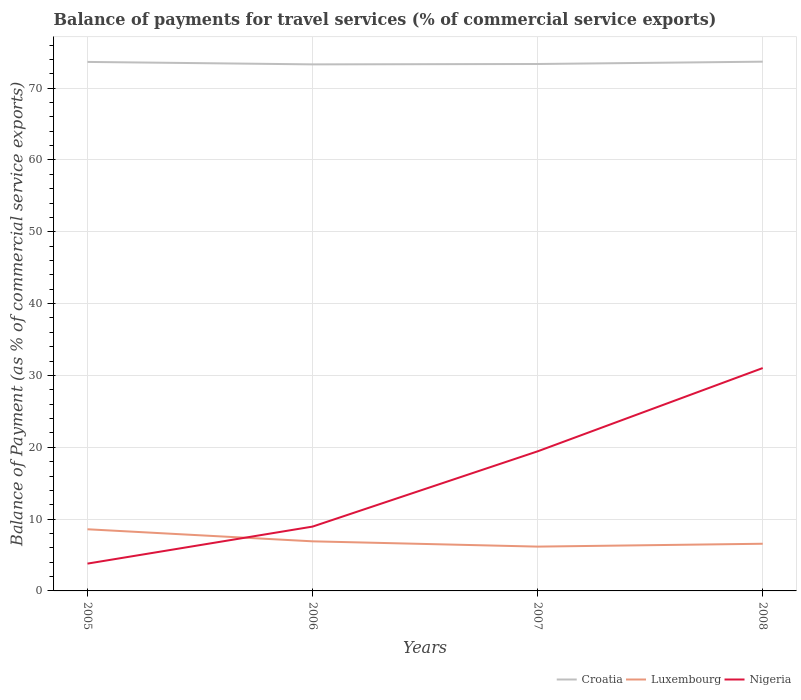Across all years, what is the maximum balance of payments for travel services in Nigeria?
Offer a terse response. 3.8. What is the total balance of payments for travel services in Nigeria in the graph?
Ensure brevity in your answer.  -22.07. What is the difference between the highest and the second highest balance of payments for travel services in Nigeria?
Provide a short and direct response. 27.23. What is the difference between the highest and the lowest balance of payments for travel services in Croatia?
Keep it short and to the point. 2. How many lines are there?
Provide a short and direct response. 3. What is the difference between two consecutive major ticks on the Y-axis?
Provide a succinct answer. 10. Does the graph contain grids?
Make the answer very short. Yes. What is the title of the graph?
Your answer should be compact. Balance of payments for travel services (% of commercial service exports). What is the label or title of the X-axis?
Give a very brief answer. Years. What is the label or title of the Y-axis?
Give a very brief answer. Balance of Payment (as % of commercial service exports). What is the Balance of Payment (as % of commercial service exports) in Croatia in 2005?
Provide a succinct answer. 73.65. What is the Balance of Payment (as % of commercial service exports) of Luxembourg in 2005?
Provide a short and direct response. 8.58. What is the Balance of Payment (as % of commercial service exports) in Nigeria in 2005?
Offer a terse response. 3.8. What is the Balance of Payment (as % of commercial service exports) of Croatia in 2006?
Your answer should be very brief. 73.31. What is the Balance of Payment (as % of commercial service exports) of Luxembourg in 2006?
Provide a succinct answer. 6.91. What is the Balance of Payment (as % of commercial service exports) in Nigeria in 2006?
Your answer should be very brief. 8.96. What is the Balance of Payment (as % of commercial service exports) of Croatia in 2007?
Provide a short and direct response. 73.36. What is the Balance of Payment (as % of commercial service exports) in Luxembourg in 2007?
Offer a terse response. 6.17. What is the Balance of Payment (as % of commercial service exports) in Nigeria in 2007?
Provide a succinct answer. 19.44. What is the Balance of Payment (as % of commercial service exports) in Croatia in 2008?
Offer a very short reply. 73.69. What is the Balance of Payment (as % of commercial service exports) in Luxembourg in 2008?
Keep it short and to the point. 6.57. What is the Balance of Payment (as % of commercial service exports) of Nigeria in 2008?
Make the answer very short. 31.03. Across all years, what is the maximum Balance of Payment (as % of commercial service exports) in Croatia?
Make the answer very short. 73.69. Across all years, what is the maximum Balance of Payment (as % of commercial service exports) of Luxembourg?
Provide a succinct answer. 8.58. Across all years, what is the maximum Balance of Payment (as % of commercial service exports) of Nigeria?
Provide a short and direct response. 31.03. Across all years, what is the minimum Balance of Payment (as % of commercial service exports) of Croatia?
Offer a very short reply. 73.31. Across all years, what is the minimum Balance of Payment (as % of commercial service exports) of Luxembourg?
Keep it short and to the point. 6.17. Across all years, what is the minimum Balance of Payment (as % of commercial service exports) in Nigeria?
Ensure brevity in your answer.  3.8. What is the total Balance of Payment (as % of commercial service exports) in Croatia in the graph?
Ensure brevity in your answer.  294.01. What is the total Balance of Payment (as % of commercial service exports) of Luxembourg in the graph?
Offer a very short reply. 28.23. What is the total Balance of Payment (as % of commercial service exports) of Nigeria in the graph?
Your answer should be compact. 63.22. What is the difference between the Balance of Payment (as % of commercial service exports) of Croatia in 2005 and that in 2006?
Provide a short and direct response. 0.34. What is the difference between the Balance of Payment (as % of commercial service exports) of Luxembourg in 2005 and that in 2006?
Offer a very short reply. 1.68. What is the difference between the Balance of Payment (as % of commercial service exports) of Nigeria in 2005 and that in 2006?
Offer a very short reply. -5.15. What is the difference between the Balance of Payment (as % of commercial service exports) in Croatia in 2005 and that in 2007?
Your answer should be compact. 0.29. What is the difference between the Balance of Payment (as % of commercial service exports) in Luxembourg in 2005 and that in 2007?
Your response must be concise. 2.41. What is the difference between the Balance of Payment (as % of commercial service exports) of Nigeria in 2005 and that in 2007?
Provide a succinct answer. -15.63. What is the difference between the Balance of Payment (as % of commercial service exports) in Croatia in 2005 and that in 2008?
Your response must be concise. -0.04. What is the difference between the Balance of Payment (as % of commercial service exports) in Luxembourg in 2005 and that in 2008?
Your answer should be compact. 2.02. What is the difference between the Balance of Payment (as % of commercial service exports) in Nigeria in 2005 and that in 2008?
Your answer should be compact. -27.23. What is the difference between the Balance of Payment (as % of commercial service exports) in Croatia in 2006 and that in 2007?
Your answer should be compact. -0.05. What is the difference between the Balance of Payment (as % of commercial service exports) of Luxembourg in 2006 and that in 2007?
Your answer should be compact. 0.73. What is the difference between the Balance of Payment (as % of commercial service exports) of Nigeria in 2006 and that in 2007?
Keep it short and to the point. -10.48. What is the difference between the Balance of Payment (as % of commercial service exports) in Croatia in 2006 and that in 2008?
Offer a very short reply. -0.38. What is the difference between the Balance of Payment (as % of commercial service exports) of Luxembourg in 2006 and that in 2008?
Keep it short and to the point. 0.34. What is the difference between the Balance of Payment (as % of commercial service exports) in Nigeria in 2006 and that in 2008?
Give a very brief answer. -22.07. What is the difference between the Balance of Payment (as % of commercial service exports) in Croatia in 2007 and that in 2008?
Keep it short and to the point. -0.32. What is the difference between the Balance of Payment (as % of commercial service exports) in Luxembourg in 2007 and that in 2008?
Keep it short and to the point. -0.4. What is the difference between the Balance of Payment (as % of commercial service exports) in Nigeria in 2007 and that in 2008?
Give a very brief answer. -11.59. What is the difference between the Balance of Payment (as % of commercial service exports) in Croatia in 2005 and the Balance of Payment (as % of commercial service exports) in Luxembourg in 2006?
Your answer should be very brief. 66.75. What is the difference between the Balance of Payment (as % of commercial service exports) of Croatia in 2005 and the Balance of Payment (as % of commercial service exports) of Nigeria in 2006?
Your answer should be very brief. 64.69. What is the difference between the Balance of Payment (as % of commercial service exports) in Luxembourg in 2005 and the Balance of Payment (as % of commercial service exports) in Nigeria in 2006?
Provide a short and direct response. -0.37. What is the difference between the Balance of Payment (as % of commercial service exports) of Croatia in 2005 and the Balance of Payment (as % of commercial service exports) of Luxembourg in 2007?
Your answer should be compact. 67.48. What is the difference between the Balance of Payment (as % of commercial service exports) of Croatia in 2005 and the Balance of Payment (as % of commercial service exports) of Nigeria in 2007?
Provide a short and direct response. 54.21. What is the difference between the Balance of Payment (as % of commercial service exports) in Luxembourg in 2005 and the Balance of Payment (as % of commercial service exports) in Nigeria in 2007?
Give a very brief answer. -10.85. What is the difference between the Balance of Payment (as % of commercial service exports) of Croatia in 2005 and the Balance of Payment (as % of commercial service exports) of Luxembourg in 2008?
Offer a terse response. 67.08. What is the difference between the Balance of Payment (as % of commercial service exports) of Croatia in 2005 and the Balance of Payment (as % of commercial service exports) of Nigeria in 2008?
Provide a short and direct response. 42.62. What is the difference between the Balance of Payment (as % of commercial service exports) in Luxembourg in 2005 and the Balance of Payment (as % of commercial service exports) in Nigeria in 2008?
Your answer should be compact. -22.45. What is the difference between the Balance of Payment (as % of commercial service exports) of Croatia in 2006 and the Balance of Payment (as % of commercial service exports) of Luxembourg in 2007?
Keep it short and to the point. 67.14. What is the difference between the Balance of Payment (as % of commercial service exports) in Croatia in 2006 and the Balance of Payment (as % of commercial service exports) in Nigeria in 2007?
Your answer should be very brief. 53.87. What is the difference between the Balance of Payment (as % of commercial service exports) of Luxembourg in 2006 and the Balance of Payment (as % of commercial service exports) of Nigeria in 2007?
Your response must be concise. -12.53. What is the difference between the Balance of Payment (as % of commercial service exports) in Croatia in 2006 and the Balance of Payment (as % of commercial service exports) in Luxembourg in 2008?
Give a very brief answer. 66.74. What is the difference between the Balance of Payment (as % of commercial service exports) of Croatia in 2006 and the Balance of Payment (as % of commercial service exports) of Nigeria in 2008?
Ensure brevity in your answer.  42.28. What is the difference between the Balance of Payment (as % of commercial service exports) in Luxembourg in 2006 and the Balance of Payment (as % of commercial service exports) in Nigeria in 2008?
Keep it short and to the point. -24.12. What is the difference between the Balance of Payment (as % of commercial service exports) of Croatia in 2007 and the Balance of Payment (as % of commercial service exports) of Luxembourg in 2008?
Provide a short and direct response. 66.8. What is the difference between the Balance of Payment (as % of commercial service exports) in Croatia in 2007 and the Balance of Payment (as % of commercial service exports) in Nigeria in 2008?
Your answer should be compact. 42.33. What is the difference between the Balance of Payment (as % of commercial service exports) in Luxembourg in 2007 and the Balance of Payment (as % of commercial service exports) in Nigeria in 2008?
Offer a terse response. -24.86. What is the average Balance of Payment (as % of commercial service exports) of Croatia per year?
Your answer should be compact. 73.5. What is the average Balance of Payment (as % of commercial service exports) of Luxembourg per year?
Keep it short and to the point. 7.06. What is the average Balance of Payment (as % of commercial service exports) in Nigeria per year?
Give a very brief answer. 15.81. In the year 2005, what is the difference between the Balance of Payment (as % of commercial service exports) in Croatia and Balance of Payment (as % of commercial service exports) in Luxembourg?
Ensure brevity in your answer.  65.07. In the year 2005, what is the difference between the Balance of Payment (as % of commercial service exports) of Croatia and Balance of Payment (as % of commercial service exports) of Nigeria?
Provide a succinct answer. 69.85. In the year 2005, what is the difference between the Balance of Payment (as % of commercial service exports) of Luxembourg and Balance of Payment (as % of commercial service exports) of Nigeria?
Offer a very short reply. 4.78. In the year 2006, what is the difference between the Balance of Payment (as % of commercial service exports) of Croatia and Balance of Payment (as % of commercial service exports) of Luxembourg?
Make the answer very short. 66.4. In the year 2006, what is the difference between the Balance of Payment (as % of commercial service exports) of Croatia and Balance of Payment (as % of commercial service exports) of Nigeria?
Offer a very short reply. 64.35. In the year 2006, what is the difference between the Balance of Payment (as % of commercial service exports) of Luxembourg and Balance of Payment (as % of commercial service exports) of Nigeria?
Offer a very short reply. -2.05. In the year 2007, what is the difference between the Balance of Payment (as % of commercial service exports) in Croatia and Balance of Payment (as % of commercial service exports) in Luxembourg?
Provide a succinct answer. 67.19. In the year 2007, what is the difference between the Balance of Payment (as % of commercial service exports) of Croatia and Balance of Payment (as % of commercial service exports) of Nigeria?
Keep it short and to the point. 53.93. In the year 2007, what is the difference between the Balance of Payment (as % of commercial service exports) in Luxembourg and Balance of Payment (as % of commercial service exports) in Nigeria?
Provide a succinct answer. -13.27. In the year 2008, what is the difference between the Balance of Payment (as % of commercial service exports) of Croatia and Balance of Payment (as % of commercial service exports) of Luxembourg?
Ensure brevity in your answer.  67.12. In the year 2008, what is the difference between the Balance of Payment (as % of commercial service exports) of Croatia and Balance of Payment (as % of commercial service exports) of Nigeria?
Offer a terse response. 42.66. In the year 2008, what is the difference between the Balance of Payment (as % of commercial service exports) in Luxembourg and Balance of Payment (as % of commercial service exports) in Nigeria?
Your answer should be compact. -24.46. What is the ratio of the Balance of Payment (as % of commercial service exports) in Croatia in 2005 to that in 2006?
Provide a short and direct response. 1. What is the ratio of the Balance of Payment (as % of commercial service exports) of Luxembourg in 2005 to that in 2006?
Your answer should be very brief. 1.24. What is the ratio of the Balance of Payment (as % of commercial service exports) of Nigeria in 2005 to that in 2006?
Provide a succinct answer. 0.42. What is the ratio of the Balance of Payment (as % of commercial service exports) of Luxembourg in 2005 to that in 2007?
Keep it short and to the point. 1.39. What is the ratio of the Balance of Payment (as % of commercial service exports) in Nigeria in 2005 to that in 2007?
Your answer should be very brief. 0.2. What is the ratio of the Balance of Payment (as % of commercial service exports) of Croatia in 2005 to that in 2008?
Offer a very short reply. 1. What is the ratio of the Balance of Payment (as % of commercial service exports) in Luxembourg in 2005 to that in 2008?
Make the answer very short. 1.31. What is the ratio of the Balance of Payment (as % of commercial service exports) in Nigeria in 2005 to that in 2008?
Provide a succinct answer. 0.12. What is the ratio of the Balance of Payment (as % of commercial service exports) of Croatia in 2006 to that in 2007?
Offer a very short reply. 1. What is the ratio of the Balance of Payment (as % of commercial service exports) of Luxembourg in 2006 to that in 2007?
Provide a succinct answer. 1.12. What is the ratio of the Balance of Payment (as % of commercial service exports) in Nigeria in 2006 to that in 2007?
Your response must be concise. 0.46. What is the ratio of the Balance of Payment (as % of commercial service exports) in Croatia in 2006 to that in 2008?
Offer a very short reply. 0.99. What is the ratio of the Balance of Payment (as % of commercial service exports) in Luxembourg in 2006 to that in 2008?
Give a very brief answer. 1.05. What is the ratio of the Balance of Payment (as % of commercial service exports) of Nigeria in 2006 to that in 2008?
Your response must be concise. 0.29. What is the ratio of the Balance of Payment (as % of commercial service exports) of Croatia in 2007 to that in 2008?
Your answer should be very brief. 1. What is the ratio of the Balance of Payment (as % of commercial service exports) in Luxembourg in 2007 to that in 2008?
Ensure brevity in your answer.  0.94. What is the ratio of the Balance of Payment (as % of commercial service exports) in Nigeria in 2007 to that in 2008?
Your response must be concise. 0.63. What is the difference between the highest and the second highest Balance of Payment (as % of commercial service exports) in Croatia?
Ensure brevity in your answer.  0.04. What is the difference between the highest and the second highest Balance of Payment (as % of commercial service exports) in Luxembourg?
Offer a terse response. 1.68. What is the difference between the highest and the second highest Balance of Payment (as % of commercial service exports) of Nigeria?
Give a very brief answer. 11.59. What is the difference between the highest and the lowest Balance of Payment (as % of commercial service exports) of Croatia?
Provide a succinct answer. 0.38. What is the difference between the highest and the lowest Balance of Payment (as % of commercial service exports) of Luxembourg?
Provide a short and direct response. 2.41. What is the difference between the highest and the lowest Balance of Payment (as % of commercial service exports) in Nigeria?
Keep it short and to the point. 27.23. 